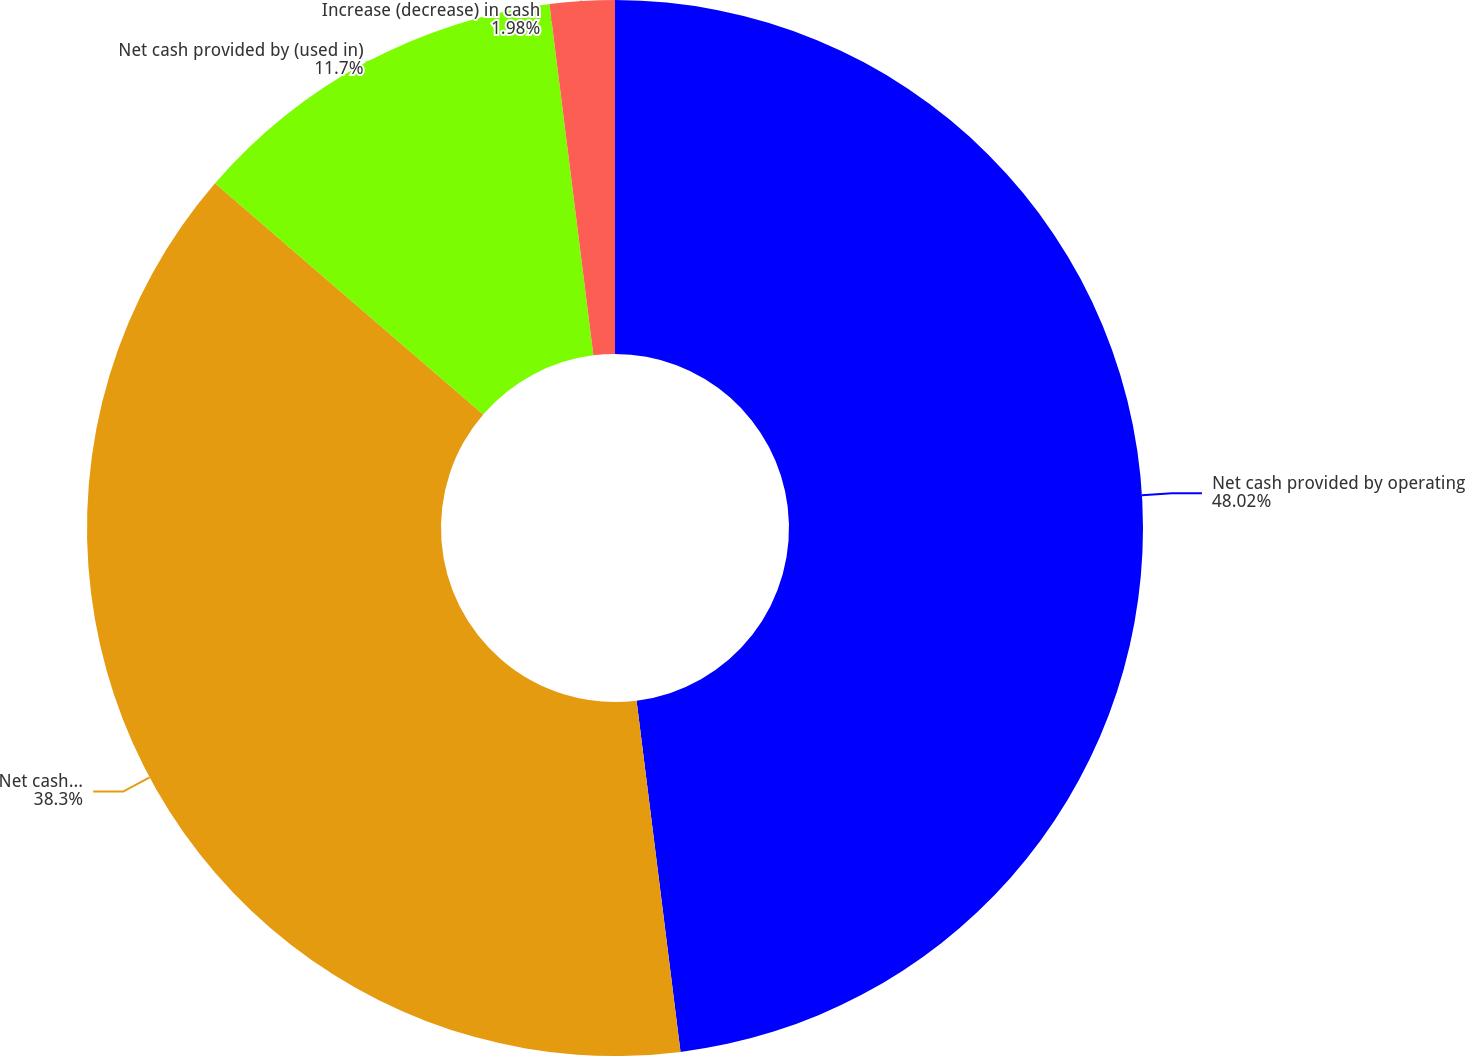<chart> <loc_0><loc_0><loc_500><loc_500><pie_chart><fcel>Net cash provided by operating<fcel>Net cash used in investing<fcel>Net cash provided by (used in)<fcel>Increase (decrease) in cash<nl><fcel>48.02%<fcel>38.3%<fcel>11.7%<fcel>1.98%<nl></chart> 